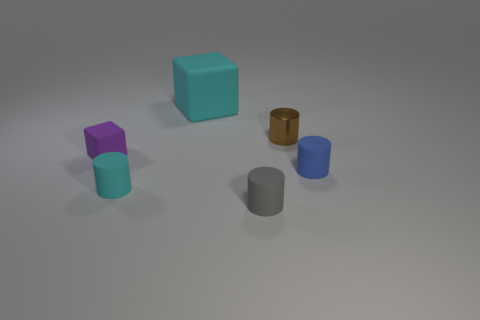Are there any cyan blocks that are in front of the purple rubber object that is left of the tiny cylinder that is behind the tiny matte block?
Your answer should be compact. No. Are there any cyan blocks to the right of the small cyan object?
Keep it short and to the point. Yes. What number of other cylinders have the same color as the small shiny cylinder?
Offer a very short reply. 0. What size is the gray cylinder that is made of the same material as the purple object?
Your response must be concise. Small. How big is the cylinder to the left of the block that is behind the rubber cube in front of the large rubber object?
Your response must be concise. Small. What is the size of the cyan matte thing that is behind the tiny brown cylinder?
Give a very brief answer. Large. What number of green things are either small metallic cylinders or large objects?
Provide a short and direct response. 0. Are there any green matte cubes that have the same size as the cyan matte cylinder?
Ensure brevity in your answer.  No. There is a cyan cylinder that is the same size as the gray thing; what is its material?
Offer a terse response. Rubber. Do the matte cylinder that is behind the small cyan rubber cylinder and the cylinder behind the small blue cylinder have the same size?
Provide a short and direct response. Yes. 